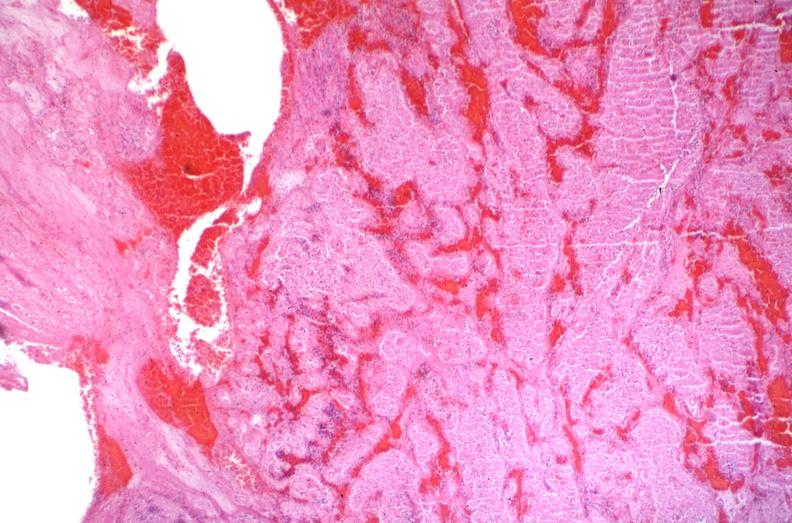what is present?
Answer the question using a single word or phrase. Cardiovascular 